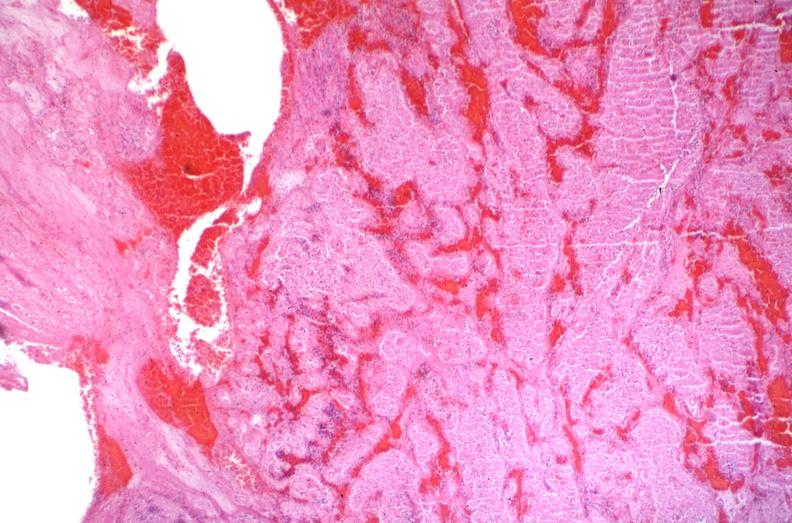what is present?
Answer the question using a single word or phrase. Cardiovascular 